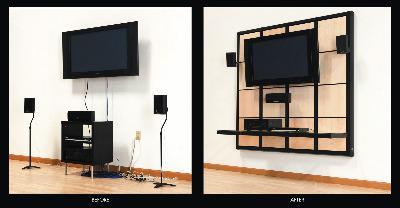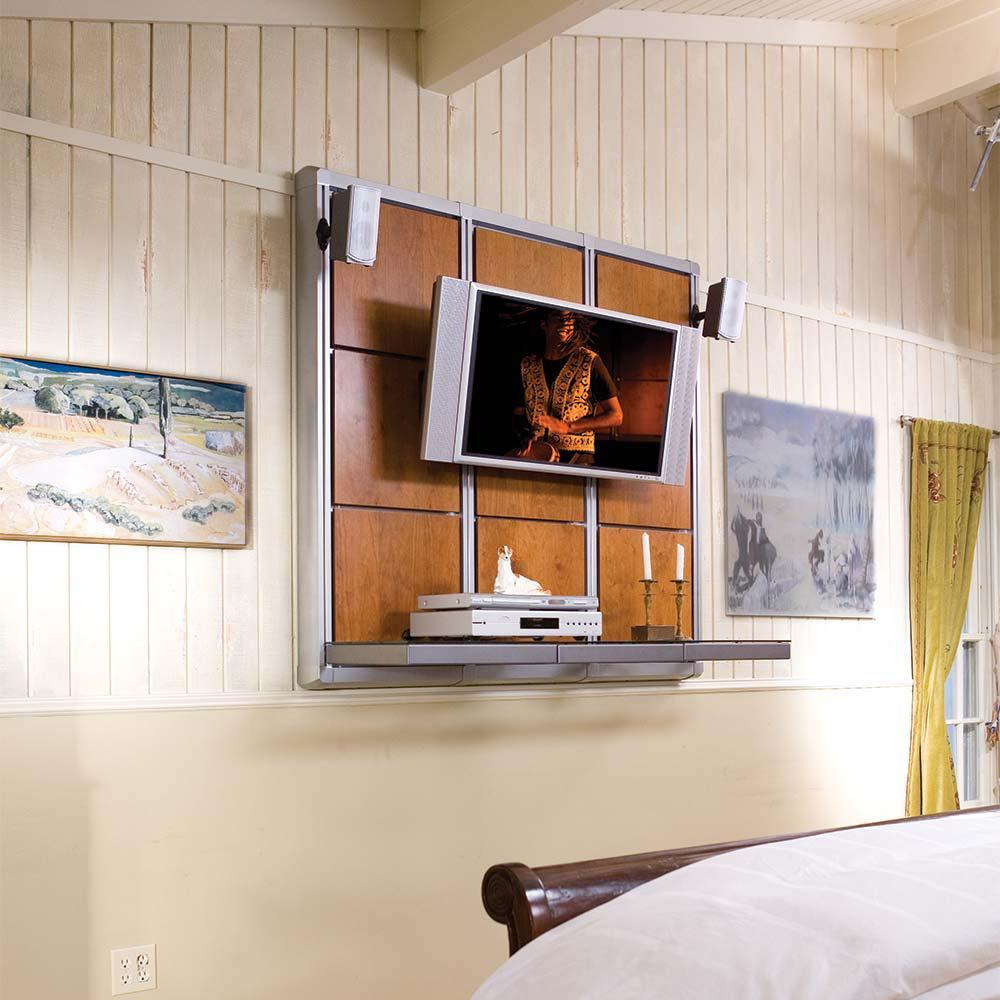The first image is the image on the left, the second image is the image on the right. Considering the images on both sides, is "Atleast one picture contains a white sofa" valid? Answer yes or no. No. The first image is the image on the left, the second image is the image on the right. Analyze the images presented: Is the assertion "At least one image has plants." valid? Answer yes or no. No. 